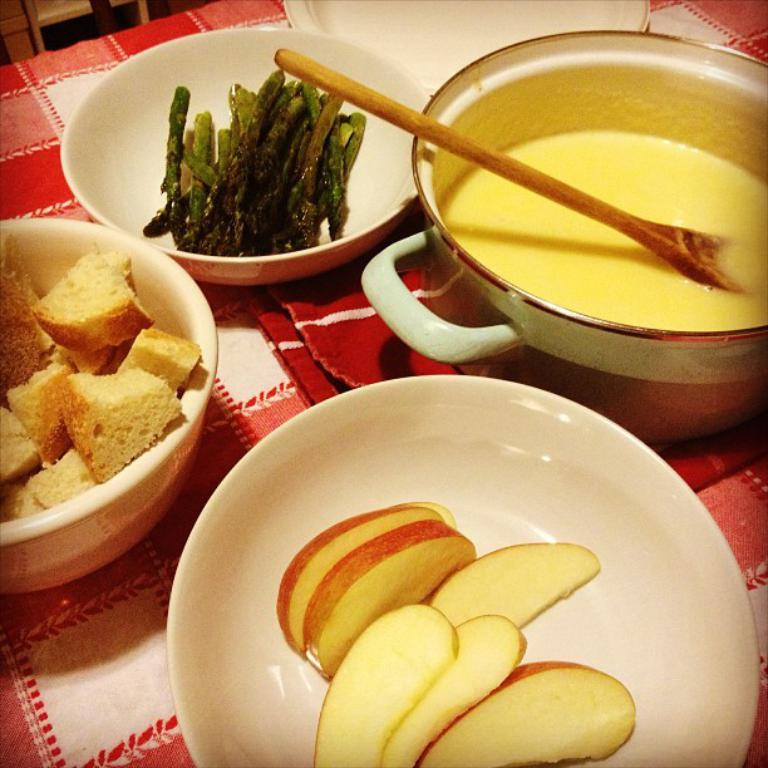What type of containers are used to serve the food items in the image? There are bowls used to serve the food items in the image. What else can be seen on the table besides the bowls? There is a plate with food items and a wooden spoon visible in the image. Where are the food items, bowls, plate, and wooden spoon placed? They are placed on a table. What type of wrench is being used by the actor in the image? There is no wrench or actor present in the image; it features food items served in bowls, a plate, a wooden spoon, and a table. How many sisters are visible in the image? There are no sisters present in the image. 